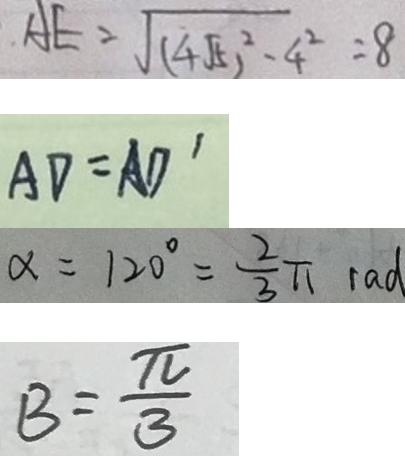Convert formula to latex. <formula><loc_0><loc_0><loc_500><loc_500>A E = \sqrt { ( 4 \sqrt { 5 } ) ^ { 2 } - 4 ^ { 2 } } = 8 
 A D = A D ^ { \prime } 
 \alpha = 1 2 0 ^ { \circ } = \frac { 2 } { 3 } \pi r a d 
 B = \frac { \pi } { 3 }</formula> 